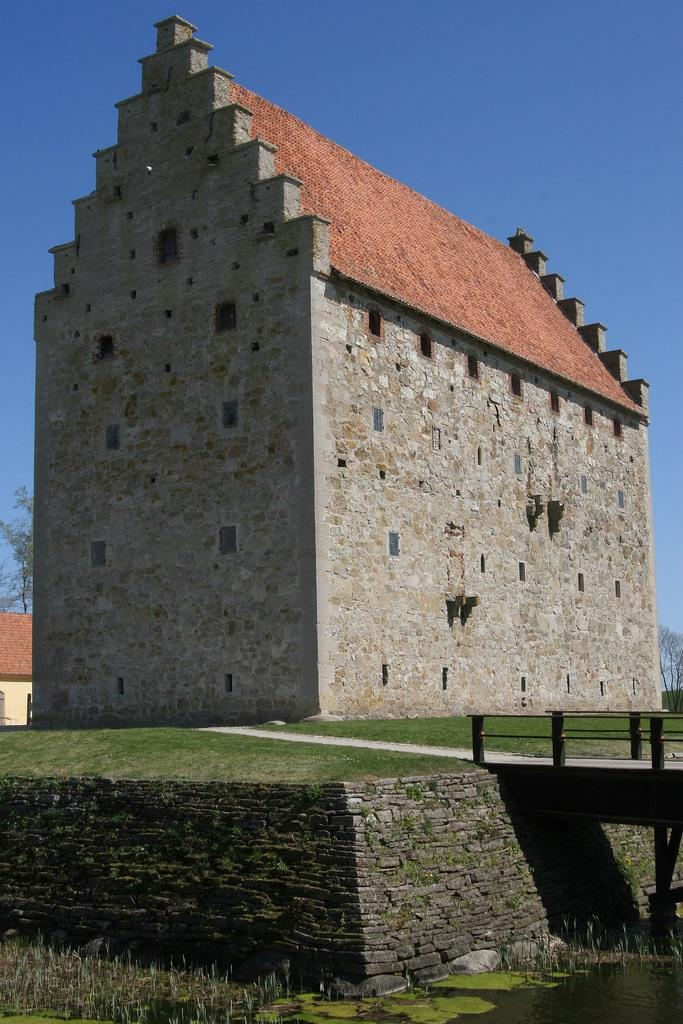What is the main structure in the center of the image? There is a building in the center of the image. What can be seen at the bottom of the image? Water, grass, a bridge, and a road are visible at the bottom of the image. What is visible in the background of the image? The sky is visible in the background of the image. What type of elbow is visible in the image? There is no elbow present in the image. How many times has the house been folded in the image? There is no house present in the image, and therefore it cannot be folded. 